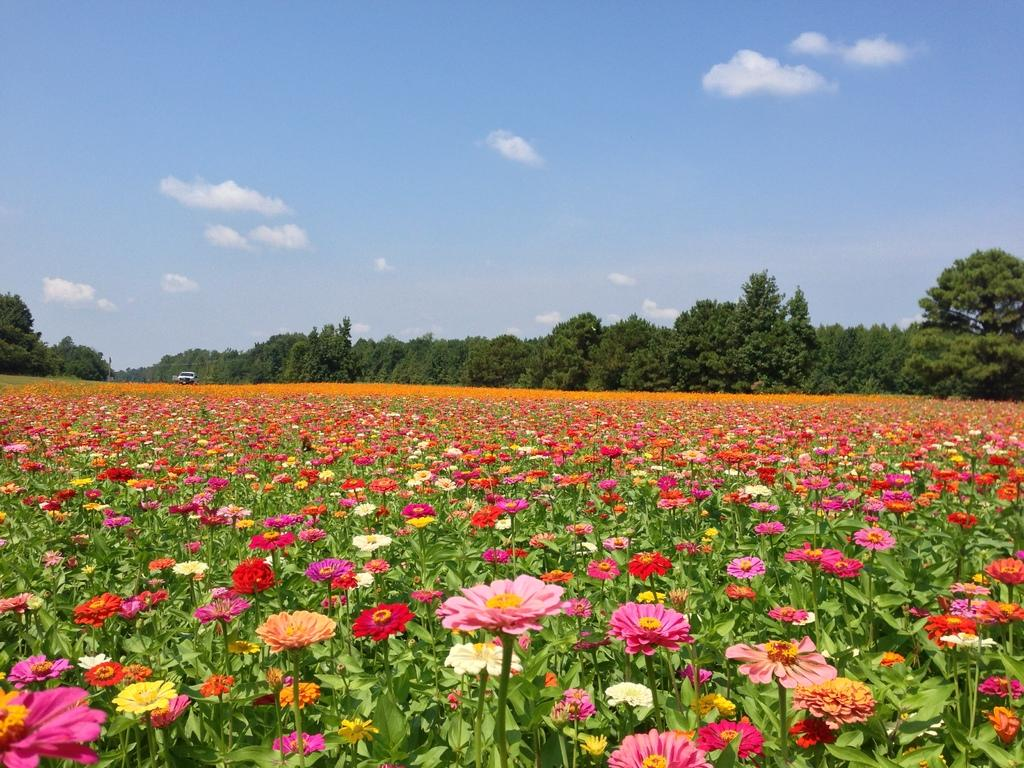What types of plants are in the foreground of the image? There are colorful flowers in the foreground of the image. What can be seen in the background of the image? There are trees and a vehicle in the background of the image. What is visible in the sky in the image? The sky is visible in the background of the image. What type of paste is being used to create the fear in the image? There is no paste or fear present in the image; it features colorful flowers, trees, a vehicle, and the sky. 